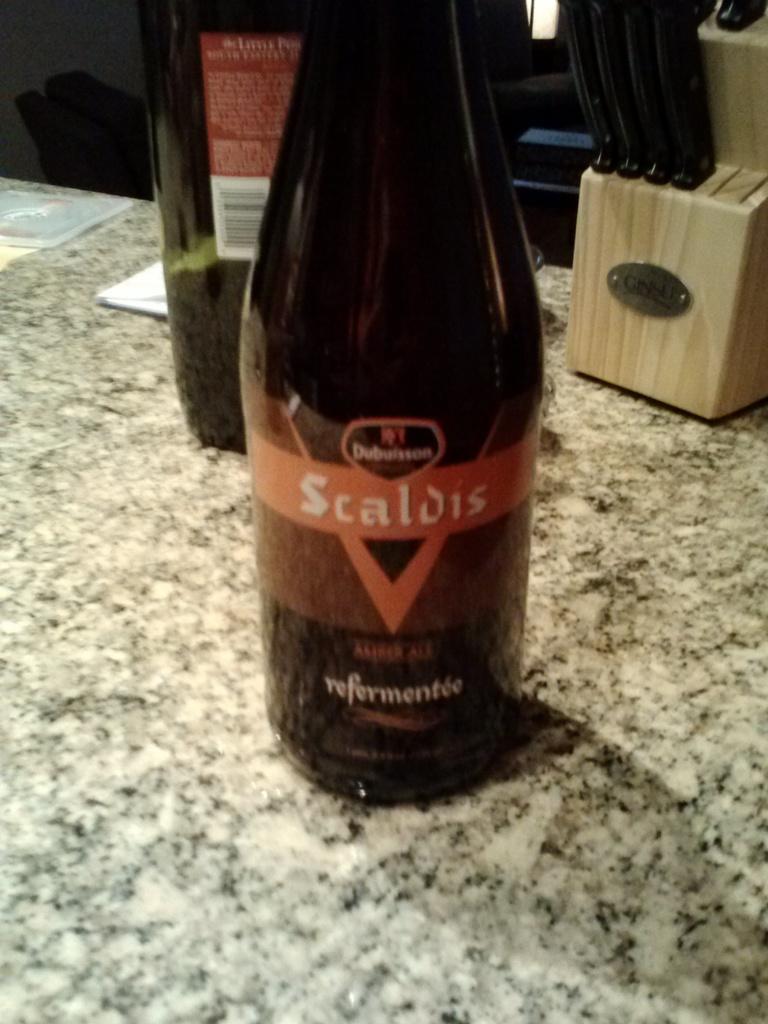What type of beverage is this?
Provide a succinct answer. Amber ale. Who produced this drink?
Your answer should be compact. Scaldis. 